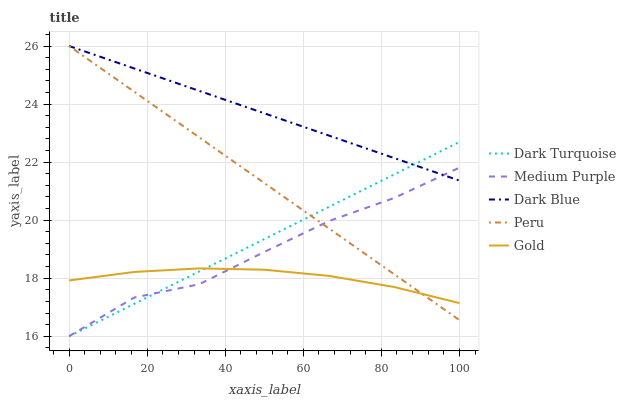Does Gold have the minimum area under the curve?
Answer yes or no. Yes. Does Dark Blue have the maximum area under the curve?
Answer yes or no. Yes. Does Dark Turquoise have the minimum area under the curve?
Answer yes or no. No. Does Dark Turquoise have the maximum area under the curve?
Answer yes or no. No. Is Dark Turquoise the smoothest?
Answer yes or no. Yes. Is Medium Purple the roughest?
Answer yes or no. Yes. Is Gold the smoothest?
Answer yes or no. No. Is Gold the roughest?
Answer yes or no. No. Does Dark Turquoise have the lowest value?
Answer yes or no. Yes. Does Gold have the lowest value?
Answer yes or no. No. Does Dark Blue have the highest value?
Answer yes or no. Yes. Does Dark Turquoise have the highest value?
Answer yes or no. No. Is Gold less than Dark Blue?
Answer yes or no. Yes. Is Dark Blue greater than Gold?
Answer yes or no. Yes. Does Dark Blue intersect Dark Turquoise?
Answer yes or no. Yes. Is Dark Blue less than Dark Turquoise?
Answer yes or no. No. Is Dark Blue greater than Dark Turquoise?
Answer yes or no. No. Does Gold intersect Dark Blue?
Answer yes or no. No. 